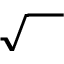Convert formula to latex. <formula><loc_0><loc_0><loc_500><loc_500>\sqrt { { } \, }</formula> 